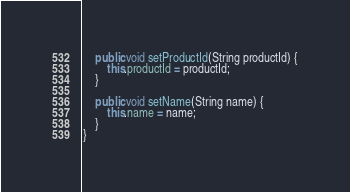<code> <loc_0><loc_0><loc_500><loc_500><_Java_>
	public void setProductId(String productId) {
		this.productId = productId;
	}

	public void setName(String name) {
		this.name = name;
	}
}</code> 